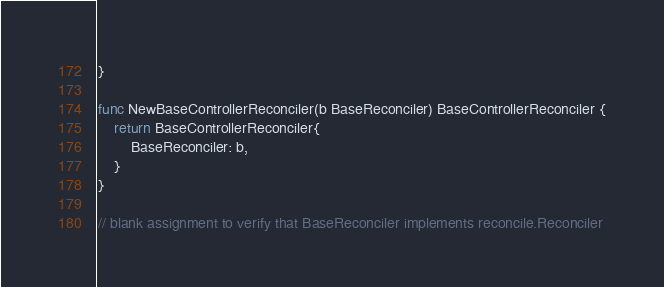<code> <loc_0><loc_0><loc_500><loc_500><_Go_>}

func NewBaseControllerReconciler(b BaseReconciler) BaseControllerReconciler {
	return BaseControllerReconciler{
		BaseReconciler: b,
	}
}

// blank assignment to verify that BaseReconciler implements reconcile.Reconciler</code> 